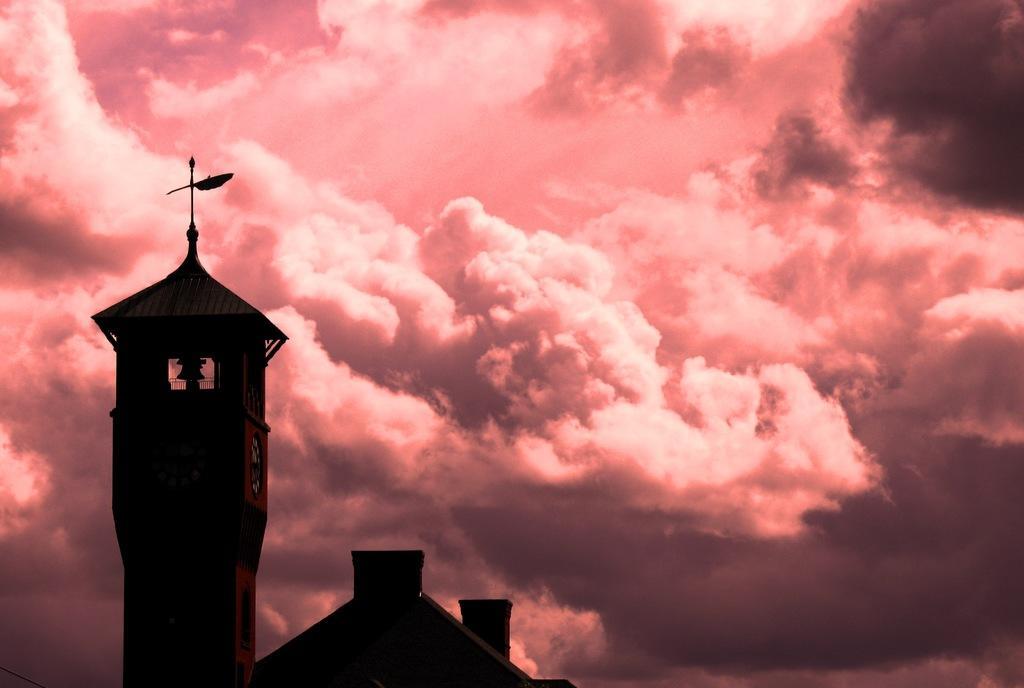In one or two sentences, can you explain what this image depicts? In this image there is a roof top of a building. To left there is a tower. There is a clock on the wall. In the background there is the sky. There are clouds in the sky. The sky is colorful. 